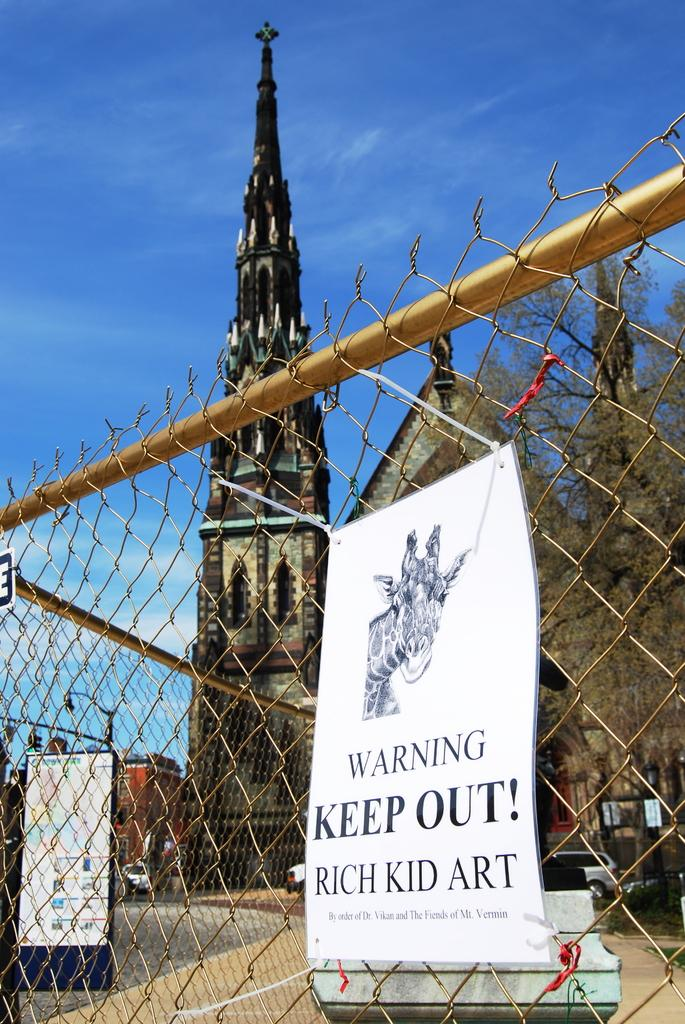What type of objects can be seen in the image? There are posters, a fence, a bench, vehicles, trees, a light pole, buildings with windows, and some other objects in the image. Can you describe the setting of the image? The image features a fence, a bench, vehicles, trees, a light pole, and buildings with windows, suggesting an outdoor urban environment. What is visible in the background of the image? The sky is visible in the background of the image. How many posters are there in the image? There are posters in the image, but the exact number is not mentioned in the facts. How many trees are wearing gloves in the image? There are trees present in the image, but there is no mention of gloves. 